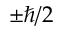Convert formula to latex. <formula><loc_0><loc_0><loc_500><loc_500>\pm \hbar { / } 2</formula> 